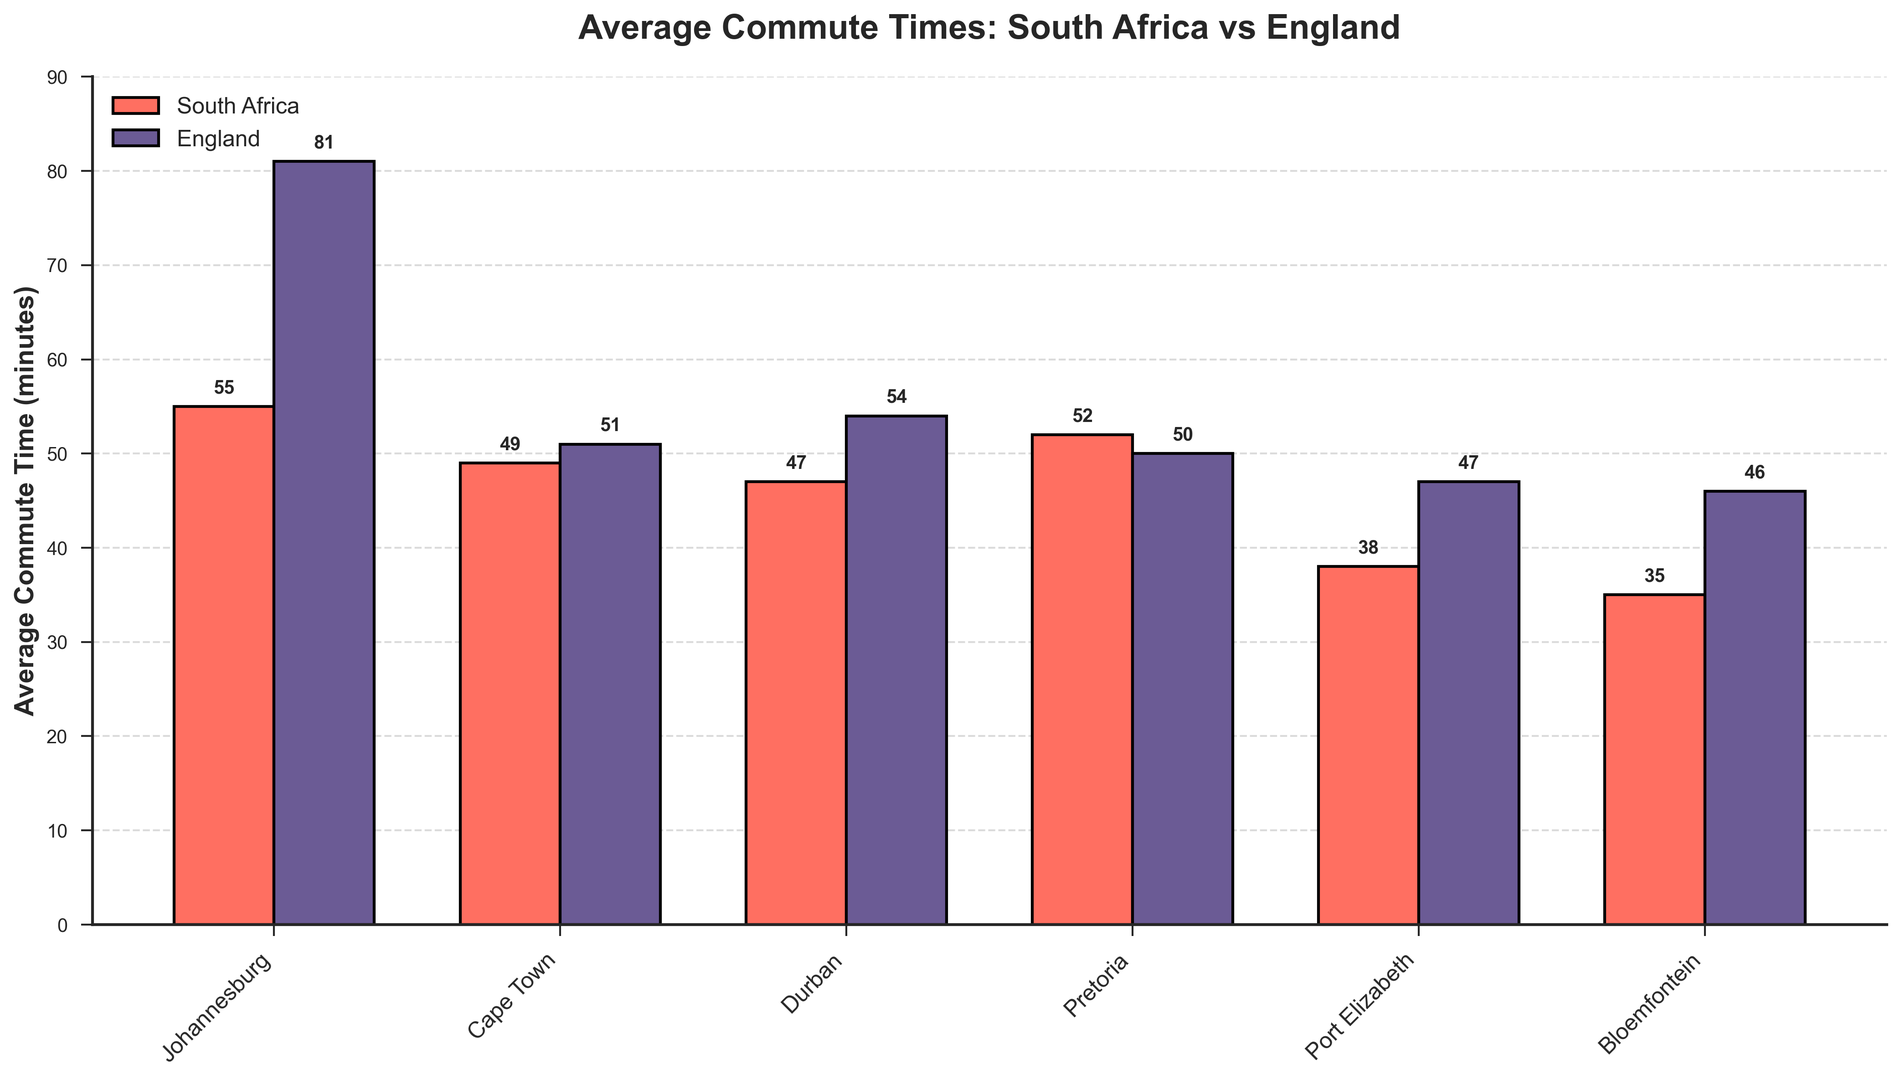What is the city with the longest average commute time in England? The longest bar for English cities in the chart represents London, with the tallest height indicating the longest commute time.
Answer: London Which city has the shortest average commute time overall? By comparing the height of all bars, Bloemfontein in South Africa has the shortest bar, indicating the shortest commute time.
Answer: Bloemfontein Which has a larger average commute time, Johannesburg or Manchester? The bar for Johannesburg is compared to the bar for Manchester. Johannesburg's bar is taller, hence has a larger average commute time.
Answer: Johannesburg What is the difference in average commute times between Pretoria and Birmingham? Pretoria's commute time is 52 minutes, while Birmingham’s is 51 minutes. Subtracting Birmingham's from Pretoria's gives 52 - 51.
Answer: 1 minute Which South African city has an average commute time closest to Nottingham? Nottingham’s bar for average commute time is 41 minutes. Among South African cities, Durban's bar at 47 minutes is similarly shorter than others.
Answer: Durban Which city, Pretoria or Sheffield, has a shorter average commute time, and by how many minutes? Compare the heights: Pretoria (52 minutes) and Sheffield (46 minutes). Subtracting gives 52 - 46.
Answer: Sheffield, 6 minutes What is the average commute time for Cape Town and Leeds combined? The sum of their average commute times: Cape Town (49) + Leeds (47) = 96. Dividing by 2 gives 96 / 2.
Answer: 48 minutes Which country, South Africa or England, has a greater variation in average commute times among its cities displayed? Compare the range of commute times in each country. South Africa ranges from 35 to 55, and England ranges from 39 to 81. England has a larger range.
Answer: England Is the average commute time in Newcastle greater than or equal to that in Port Elizabeth? Compare their commute times: Newcastle (43 minutes) and Port Elizabeth (38 minutes). 43 is greater than 38.
Answer: Yes What is the average commute time difference between London and Johannesburg? London's commute time is 81 minutes, and Johannesburg’s is 55 minutes. Subtracting gives 81 - 55.
Answer: 26 minutes 